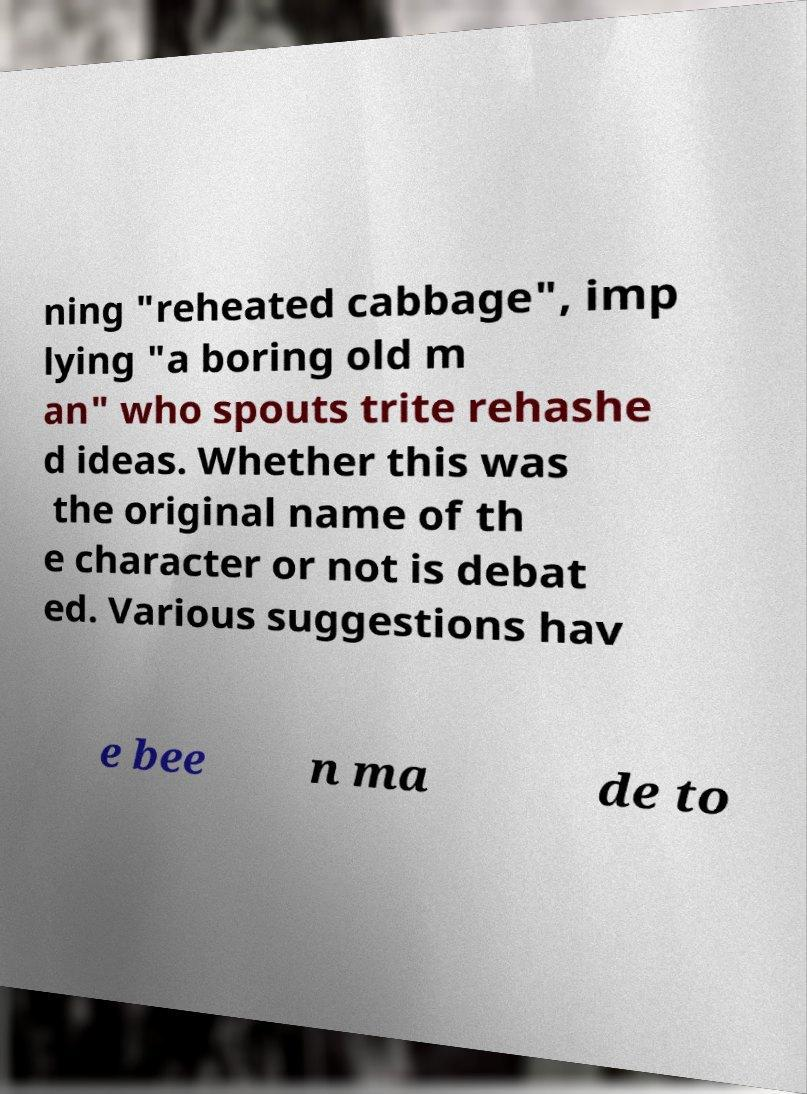Can you read and provide the text displayed in the image?This photo seems to have some interesting text. Can you extract and type it out for me? ning "reheated cabbage", imp lying "a boring old m an" who spouts trite rehashe d ideas. Whether this was the original name of th e character or not is debat ed. Various suggestions hav e bee n ma de to 